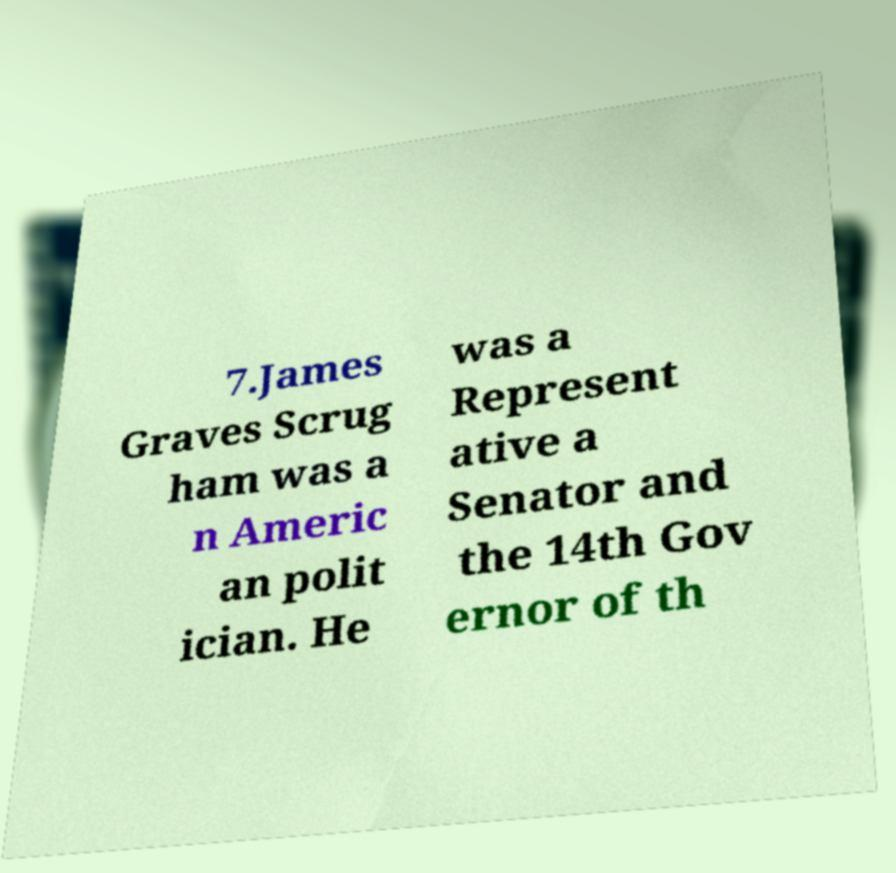Please read and relay the text visible in this image. What does it say? 7.James Graves Scrug ham was a n Americ an polit ician. He was a Represent ative a Senator and the 14th Gov ernor of th 